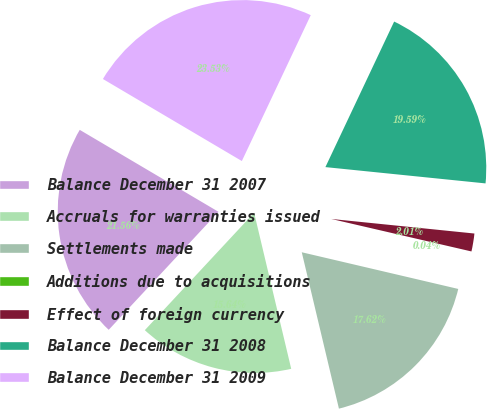Convert chart to OTSL. <chart><loc_0><loc_0><loc_500><loc_500><pie_chart><fcel>Balance December 31 2007<fcel>Accruals for warranties issued<fcel>Settlements made<fcel>Additions due to acquisitions<fcel>Effect of foreign currency<fcel>Balance December 31 2008<fcel>Balance December 31 2009<nl><fcel>21.56%<fcel>15.64%<fcel>17.62%<fcel>0.04%<fcel>2.01%<fcel>19.59%<fcel>23.53%<nl></chart> 